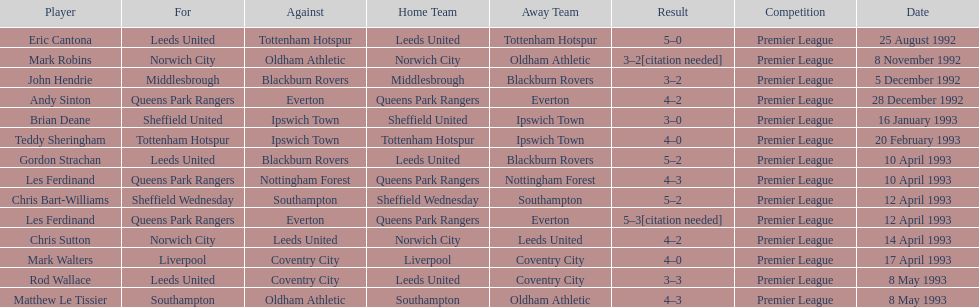Which player had the same result as mark robins? John Hendrie. 